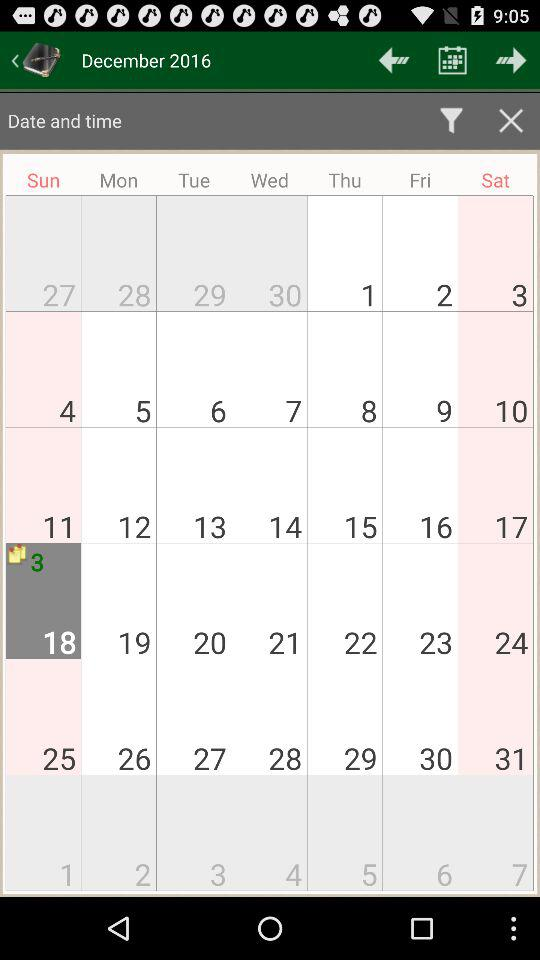Which date is selected in the calendar? The selected date is Sunday, December 18, 2016. 